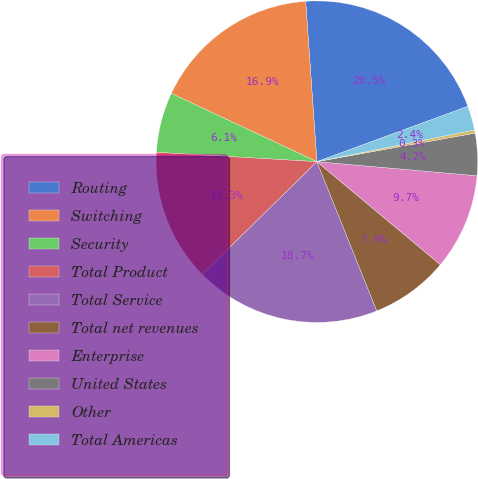<chart> <loc_0><loc_0><loc_500><loc_500><pie_chart><fcel>Routing<fcel>Switching<fcel>Security<fcel>Total Product<fcel>Total Service<fcel>Total net revenues<fcel>Enterprise<fcel>United States<fcel>Other<fcel>Total Americas<nl><fcel>20.52%<fcel>16.91%<fcel>6.05%<fcel>13.29%<fcel>18.71%<fcel>7.86%<fcel>9.67%<fcel>4.24%<fcel>0.32%<fcel>2.43%<nl></chart> 